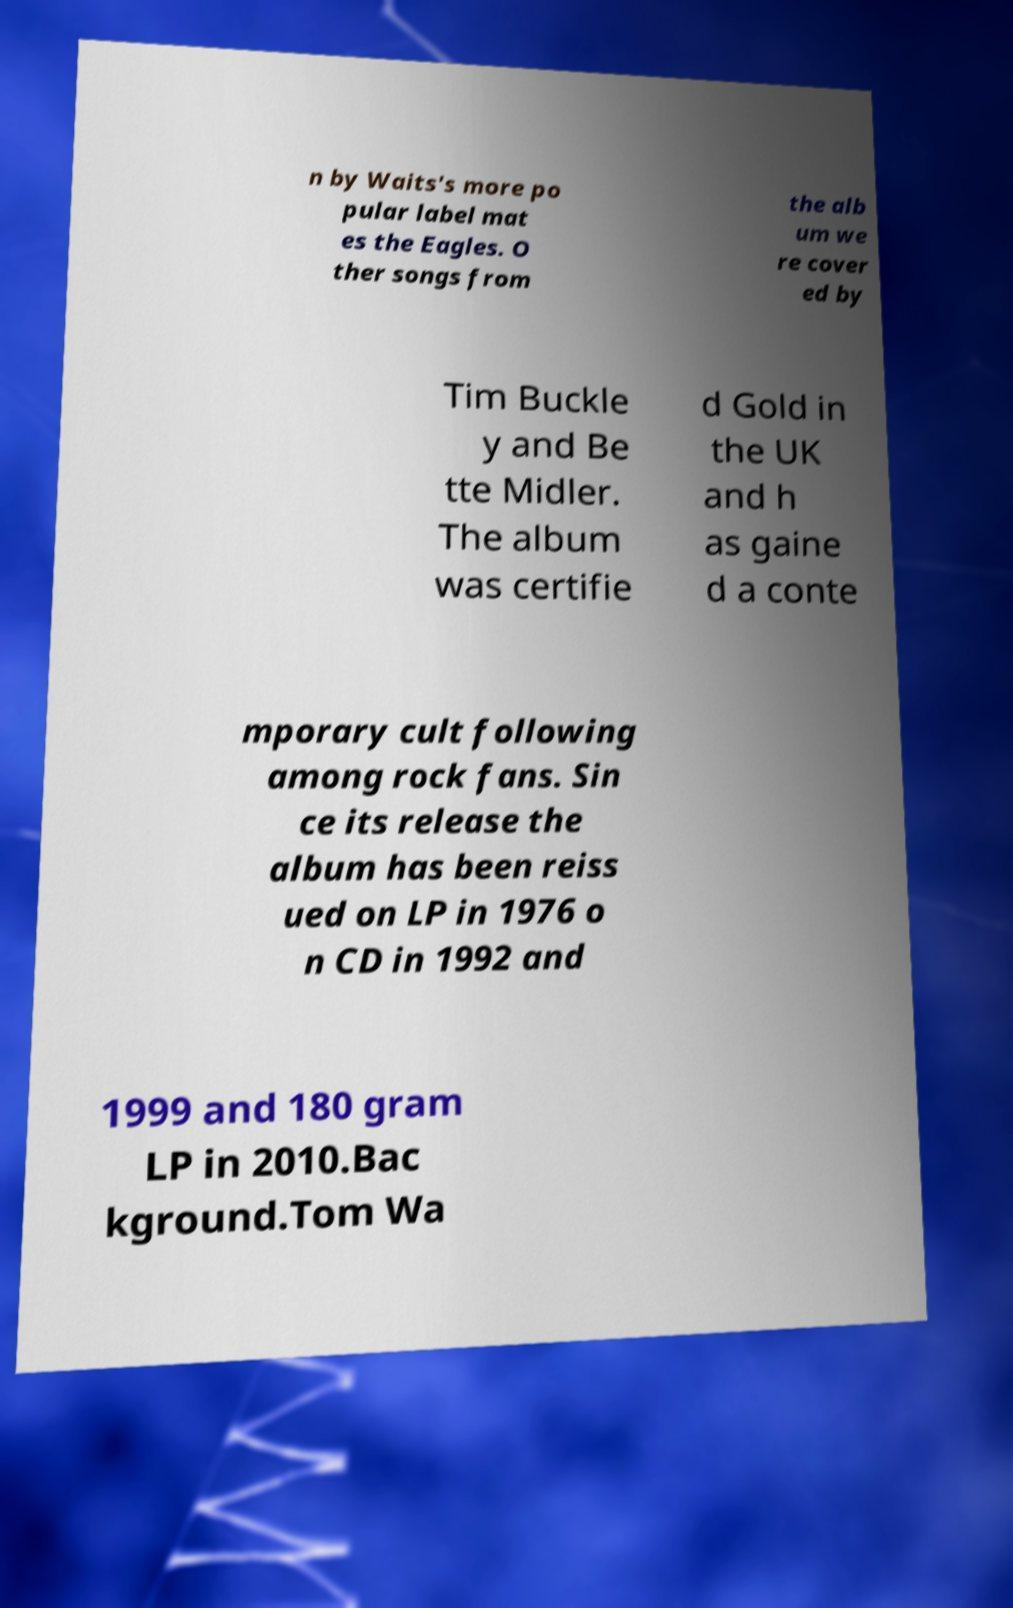Please identify and transcribe the text found in this image. n by Waits's more po pular label mat es the Eagles. O ther songs from the alb um we re cover ed by Tim Buckle y and Be tte Midler. The album was certifie d Gold in the UK and h as gaine d a conte mporary cult following among rock fans. Sin ce its release the album has been reiss ued on LP in 1976 o n CD in 1992 and 1999 and 180 gram LP in 2010.Bac kground.Tom Wa 